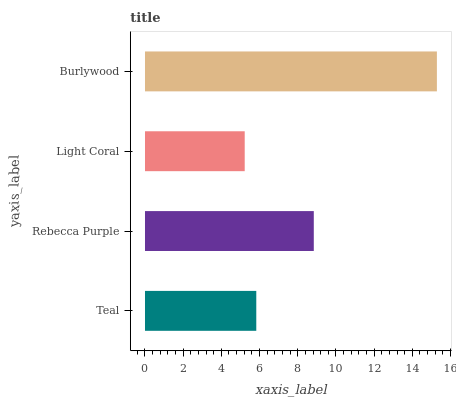Is Light Coral the minimum?
Answer yes or no. Yes. Is Burlywood the maximum?
Answer yes or no. Yes. Is Rebecca Purple the minimum?
Answer yes or no. No. Is Rebecca Purple the maximum?
Answer yes or no. No. Is Rebecca Purple greater than Teal?
Answer yes or no. Yes. Is Teal less than Rebecca Purple?
Answer yes or no. Yes. Is Teal greater than Rebecca Purple?
Answer yes or no. No. Is Rebecca Purple less than Teal?
Answer yes or no. No. Is Rebecca Purple the high median?
Answer yes or no. Yes. Is Teal the low median?
Answer yes or no. Yes. Is Burlywood the high median?
Answer yes or no. No. Is Rebecca Purple the low median?
Answer yes or no. No. 